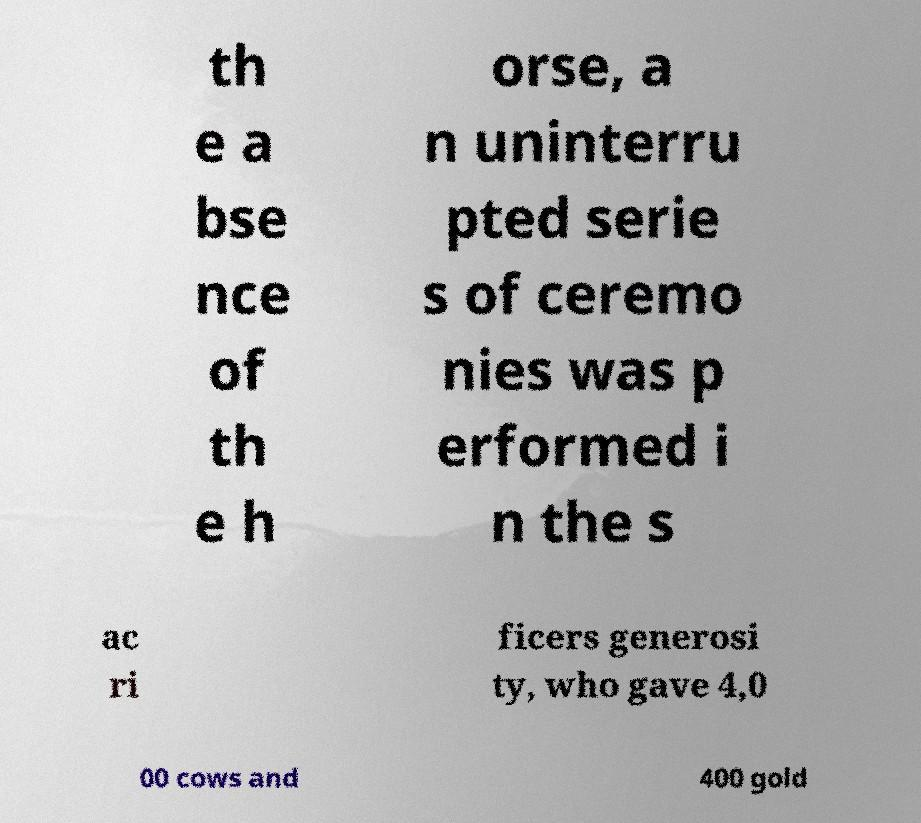There's text embedded in this image that I need extracted. Can you transcribe it verbatim? th e a bse nce of th e h orse, a n uninterru pted serie s of ceremo nies was p erformed i n the s ac ri ficers generosi ty, who gave 4,0 00 cows and 400 gold 